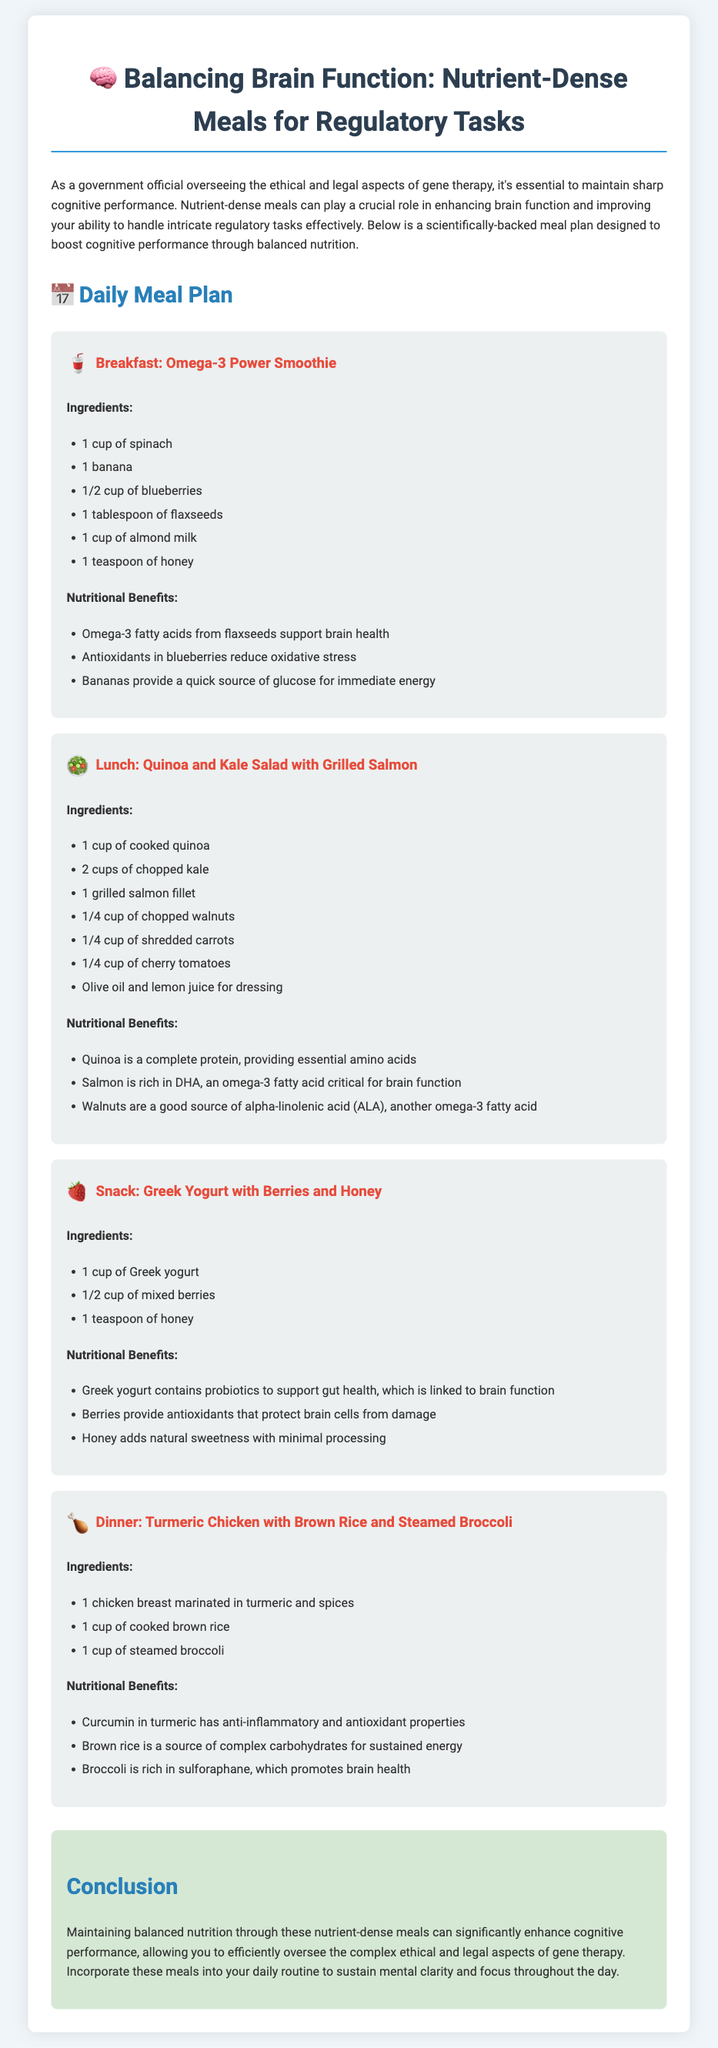What is the title of the meal plan? The title of the meal plan is presented at the top of the document, highlighting its focus on cognitive performance for regulatory tasks.
Answer: Balancing Brain Function: Nutrient-Dense Meals for Regulatory Tasks What is one of the ingredients in the breakfast smoothie? The breakfast smoothie includes a list of ingredients under the 'Breakfast' section, specifically named in the meal description.
Answer: Spinach How many cups of quinoa are used in the lunch meal? The amount of quinoa is specified under the ingredients for the 'Lunch' section in the document.
Answer: 1 cup What nutrient do blueberries provide to support brain function? The benefits of blueberries are mentioned in the 'Breakfast' section, outlining their role in reducing oxidative stress.
Answer: Antioxidants Which ingredient in the 'Dinner' meal has anti-inflammatory properties? The benefits of turmeric are explained in the 'Dinner' section, particularly its properties that support brain health.
Answer: Curcumin What type of yogurt is included as a snack? The snack section specifies the type of yogurt in the list of ingredients, highlighting its main feature.
Answer: Greek What ingredient in the lunch meal is a source of complete protein? The benefits of quinoa are detailed in the 'Lunch' section, making clear its nutritional value as a complete protein source.
Answer: Quinoa How many meals are included in the daily meal plan? The document lists the number of meals under the 'Daily Meal Plan' heading and describes each one.
Answer: Four 